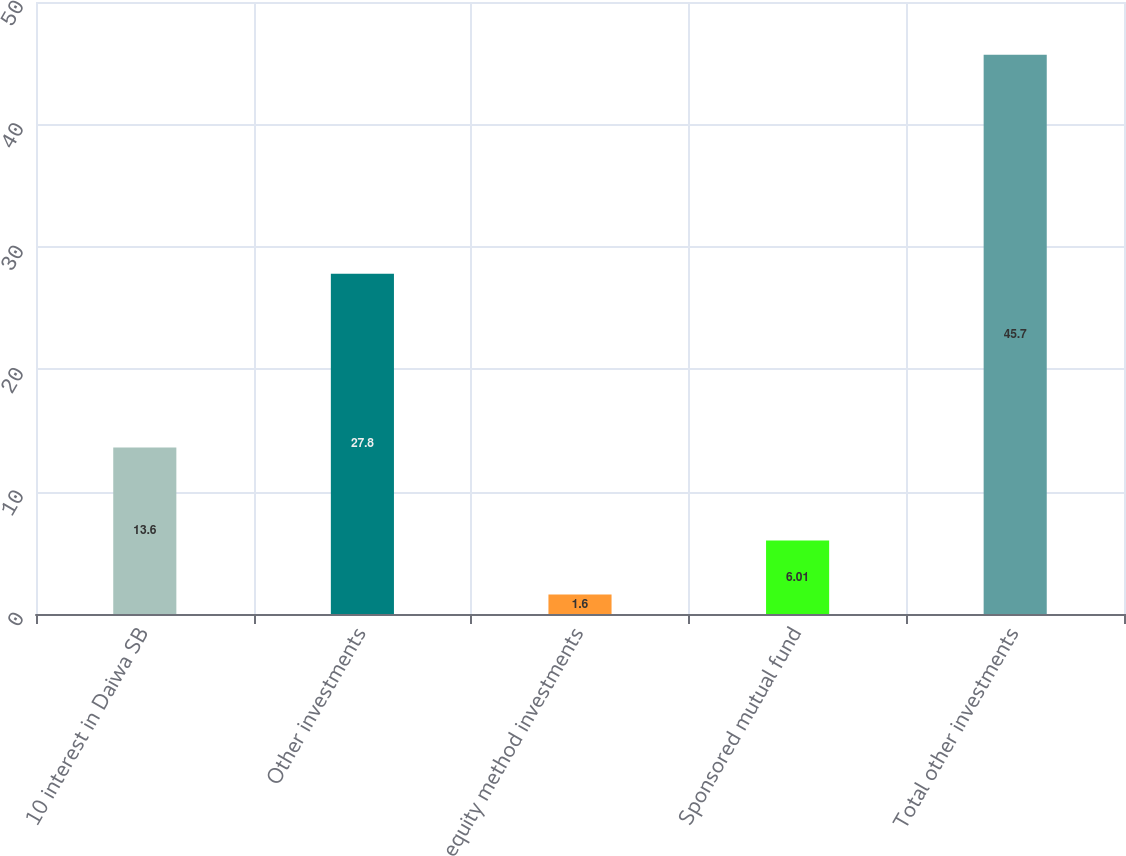<chart> <loc_0><loc_0><loc_500><loc_500><bar_chart><fcel>10 interest in Daiwa SB<fcel>Other investments<fcel>equity method investments<fcel>Sponsored mutual fund<fcel>Total other investments<nl><fcel>13.6<fcel>27.8<fcel>1.6<fcel>6.01<fcel>45.7<nl></chart> 